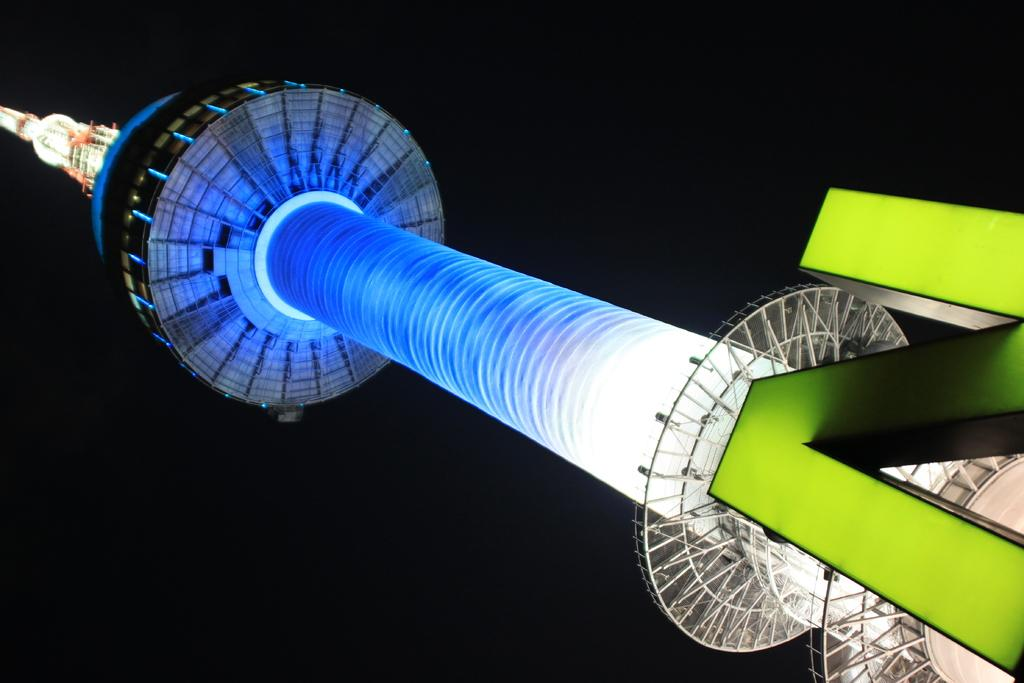What structure is the main subject of the image? There is a tower in the image. What else can be seen in the image besides the tower? There are lights and the letter 'n' visible in the image. How would you describe the overall appearance of the image? The background of the image is dark. What is the price of the potato in the image? There is no potato present in the image, so it is not possible to determine its price. 